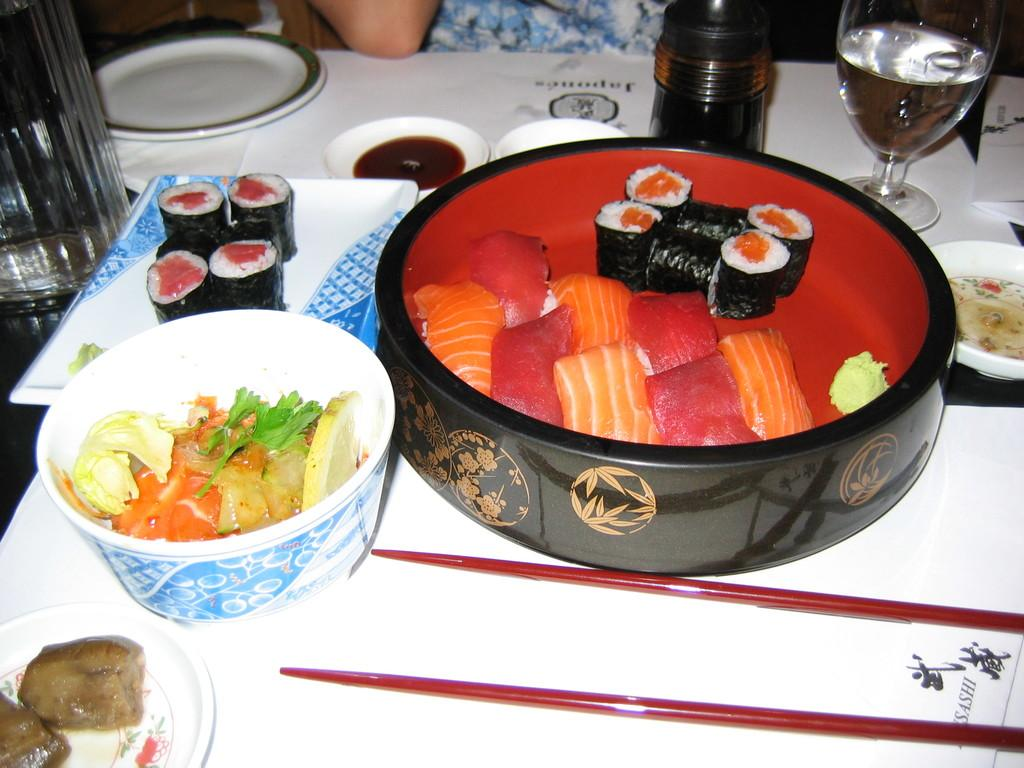What types of food items can be seen in the image? There are food items in the image, but their specific types cannot be determined without more information. What is the glass used for in the image? The purpose of the glass cannot be determined without more context, but it is likely used for holding a beverage or serving food. How many times does the person blow into the glass in the image? There is no person blowing into the glass in the image. The glass is likely used for holding a beverage or serving food, but there is no indication of anyone blowing into it. 